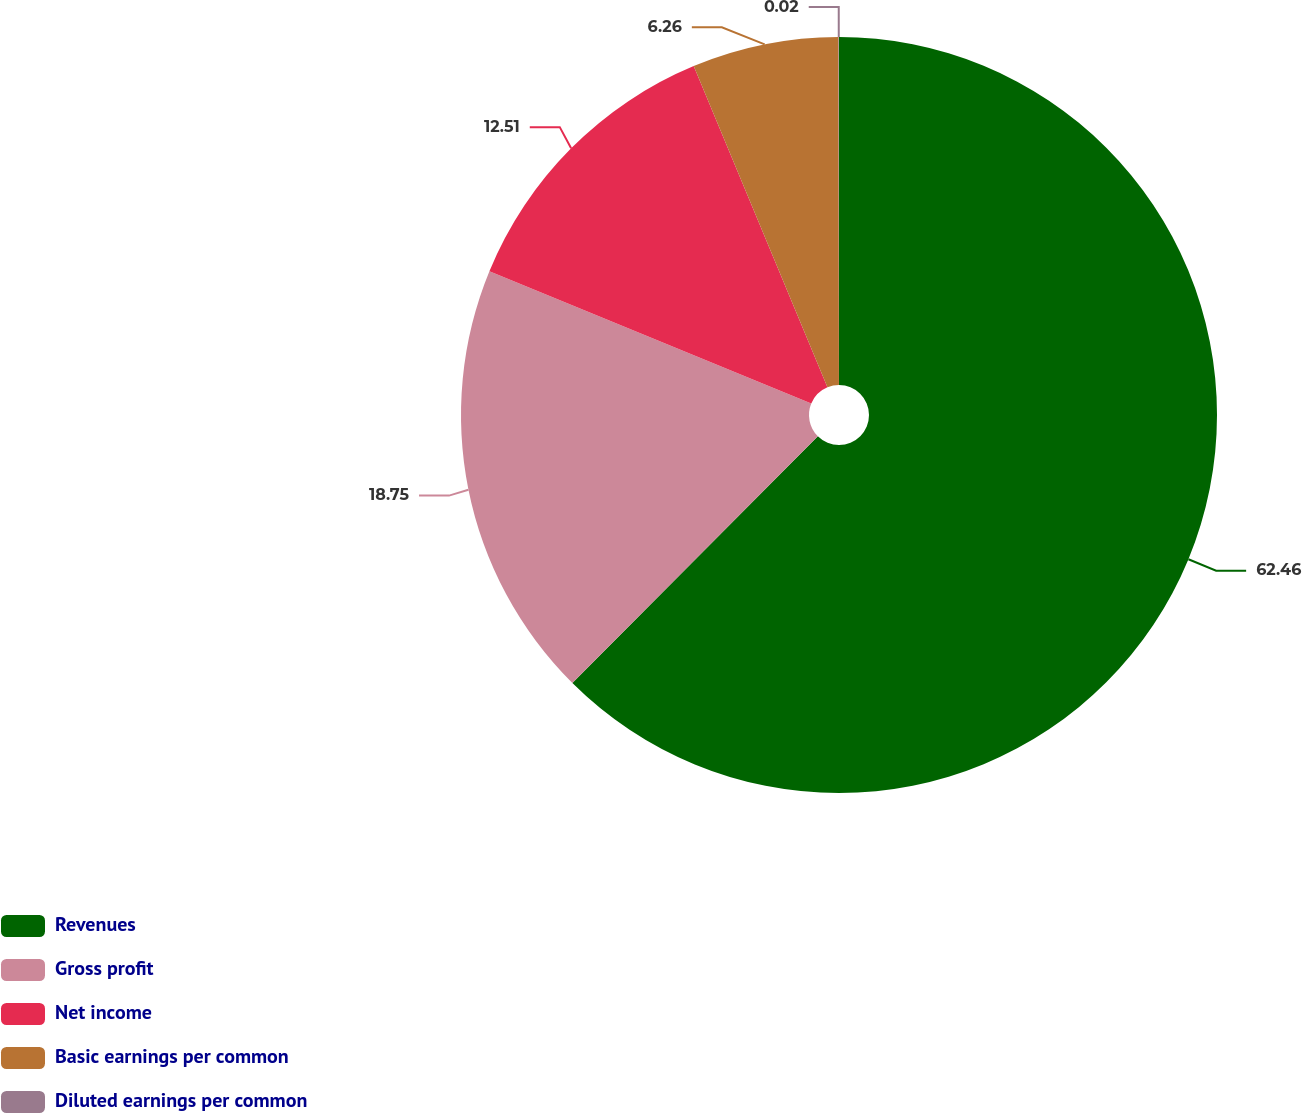<chart> <loc_0><loc_0><loc_500><loc_500><pie_chart><fcel>Revenues<fcel>Gross profit<fcel>Net income<fcel>Basic earnings per common<fcel>Diluted earnings per common<nl><fcel>62.46%<fcel>18.75%<fcel>12.51%<fcel>6.26%<fcel>0.02%<nl></chart> 